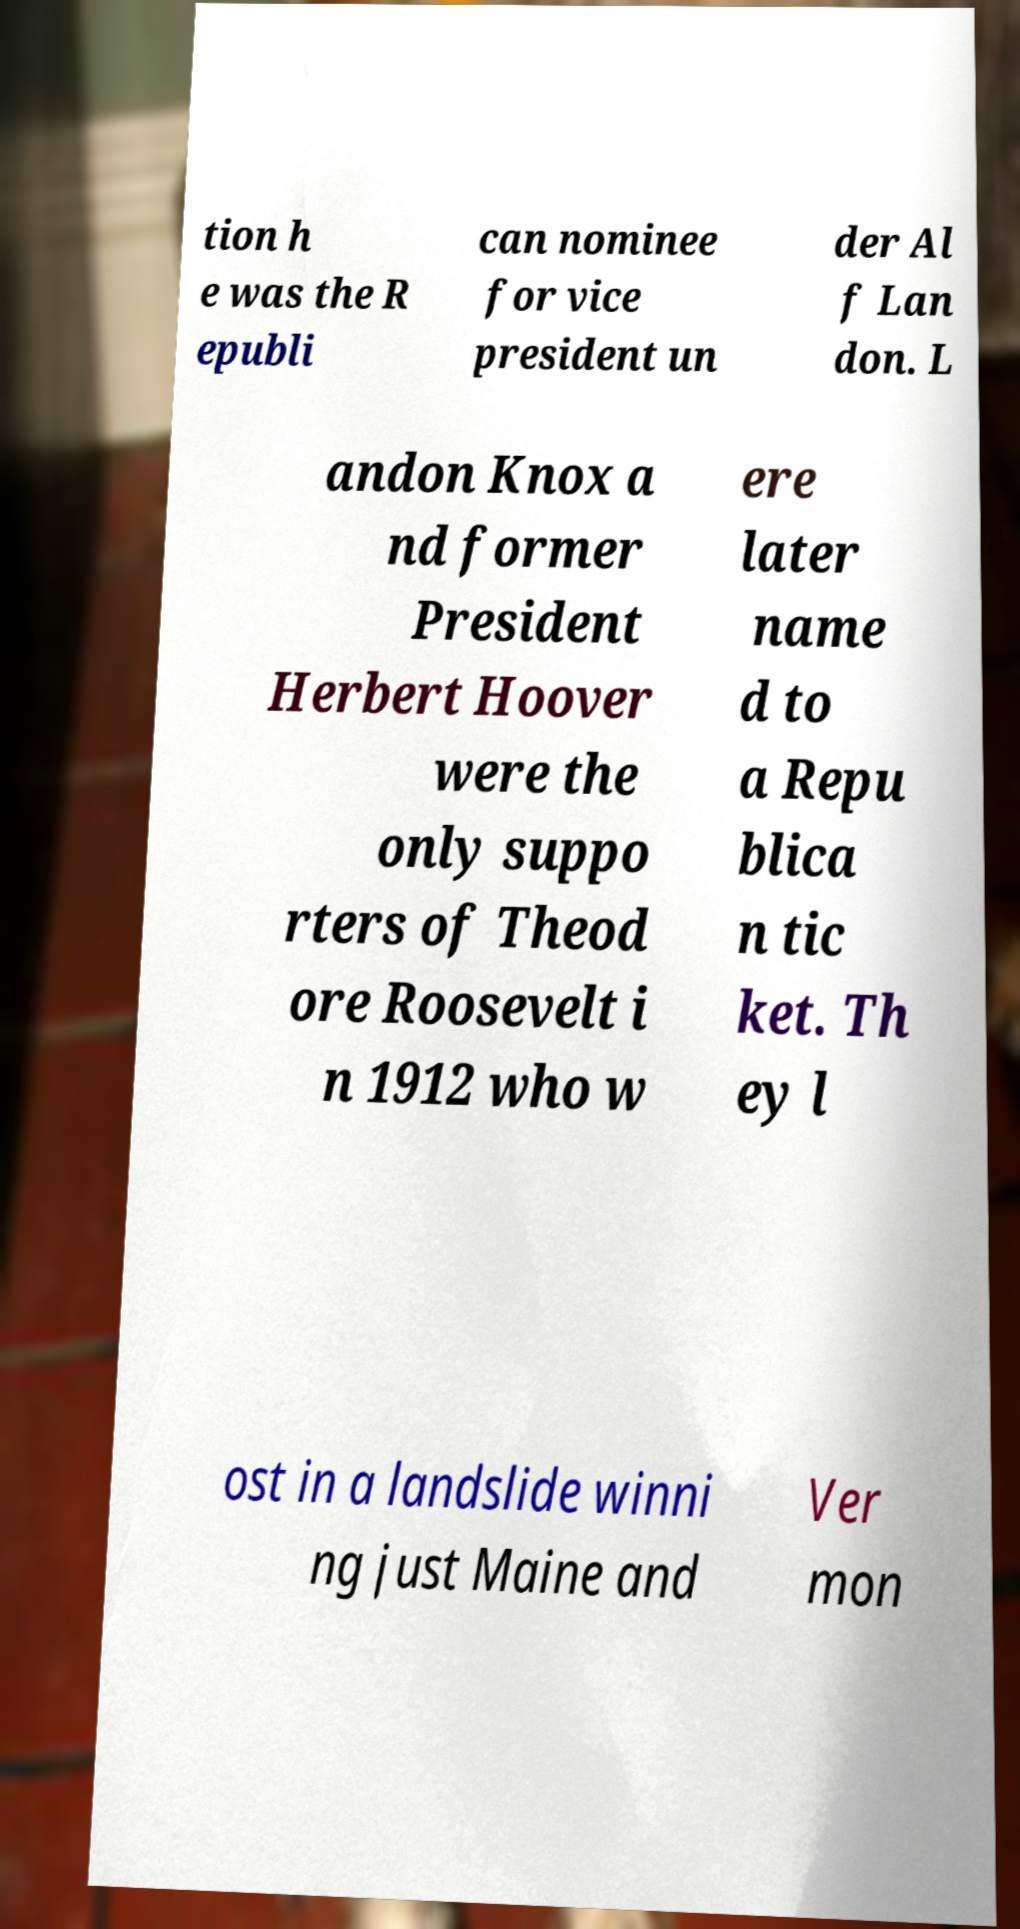For documentation purposes, I need the text within this image transcribed. Could you provide that? tion h e was the R epubli can nominee for vice president un der Al f Lan don. L andon Knox a nd former President Herbert Hoover were the only suppo rters of Theod ore Roosevelt i n 1912 who w ere later name d to a Repu blica n tic ket. Th ey l ost in a landslide winni ng just Maine and Ver mon 